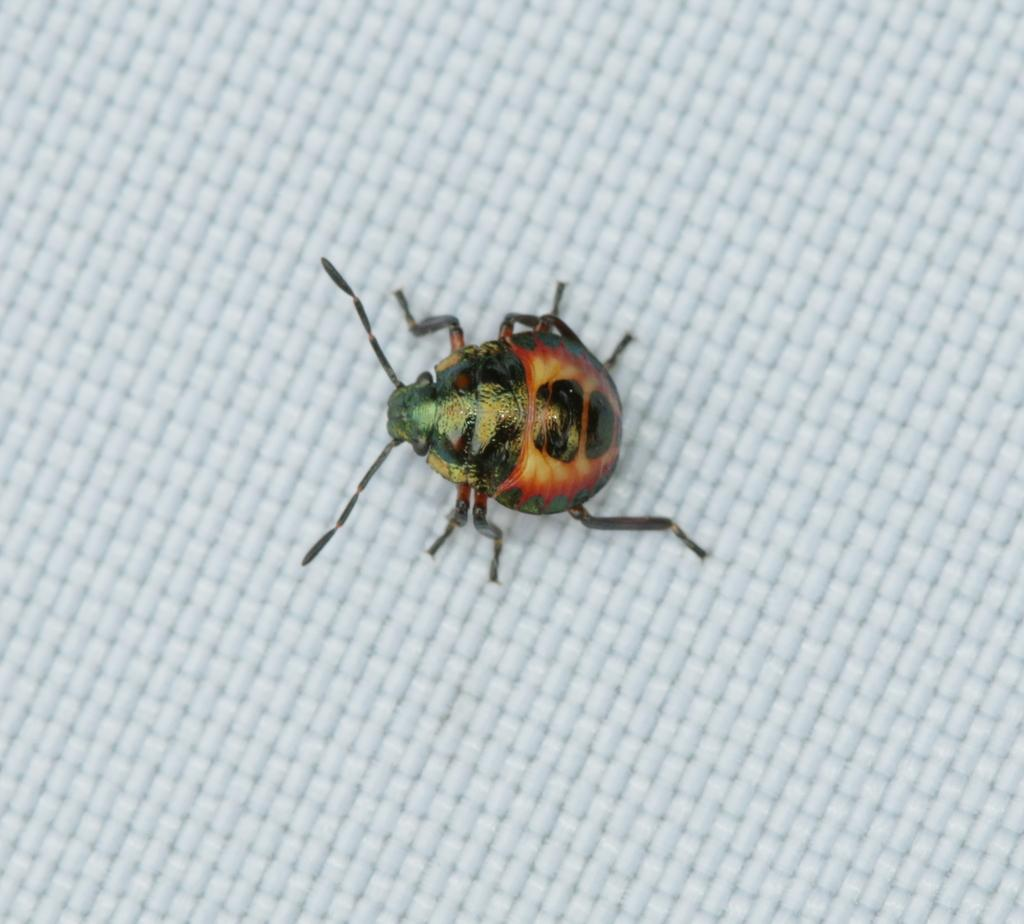What type of creature can be seen on the surface in the image? There is an insect on the surface in the image. What type of trucks can be seen in the image? There are no trucks present in the image; it features an insect on a surface. 